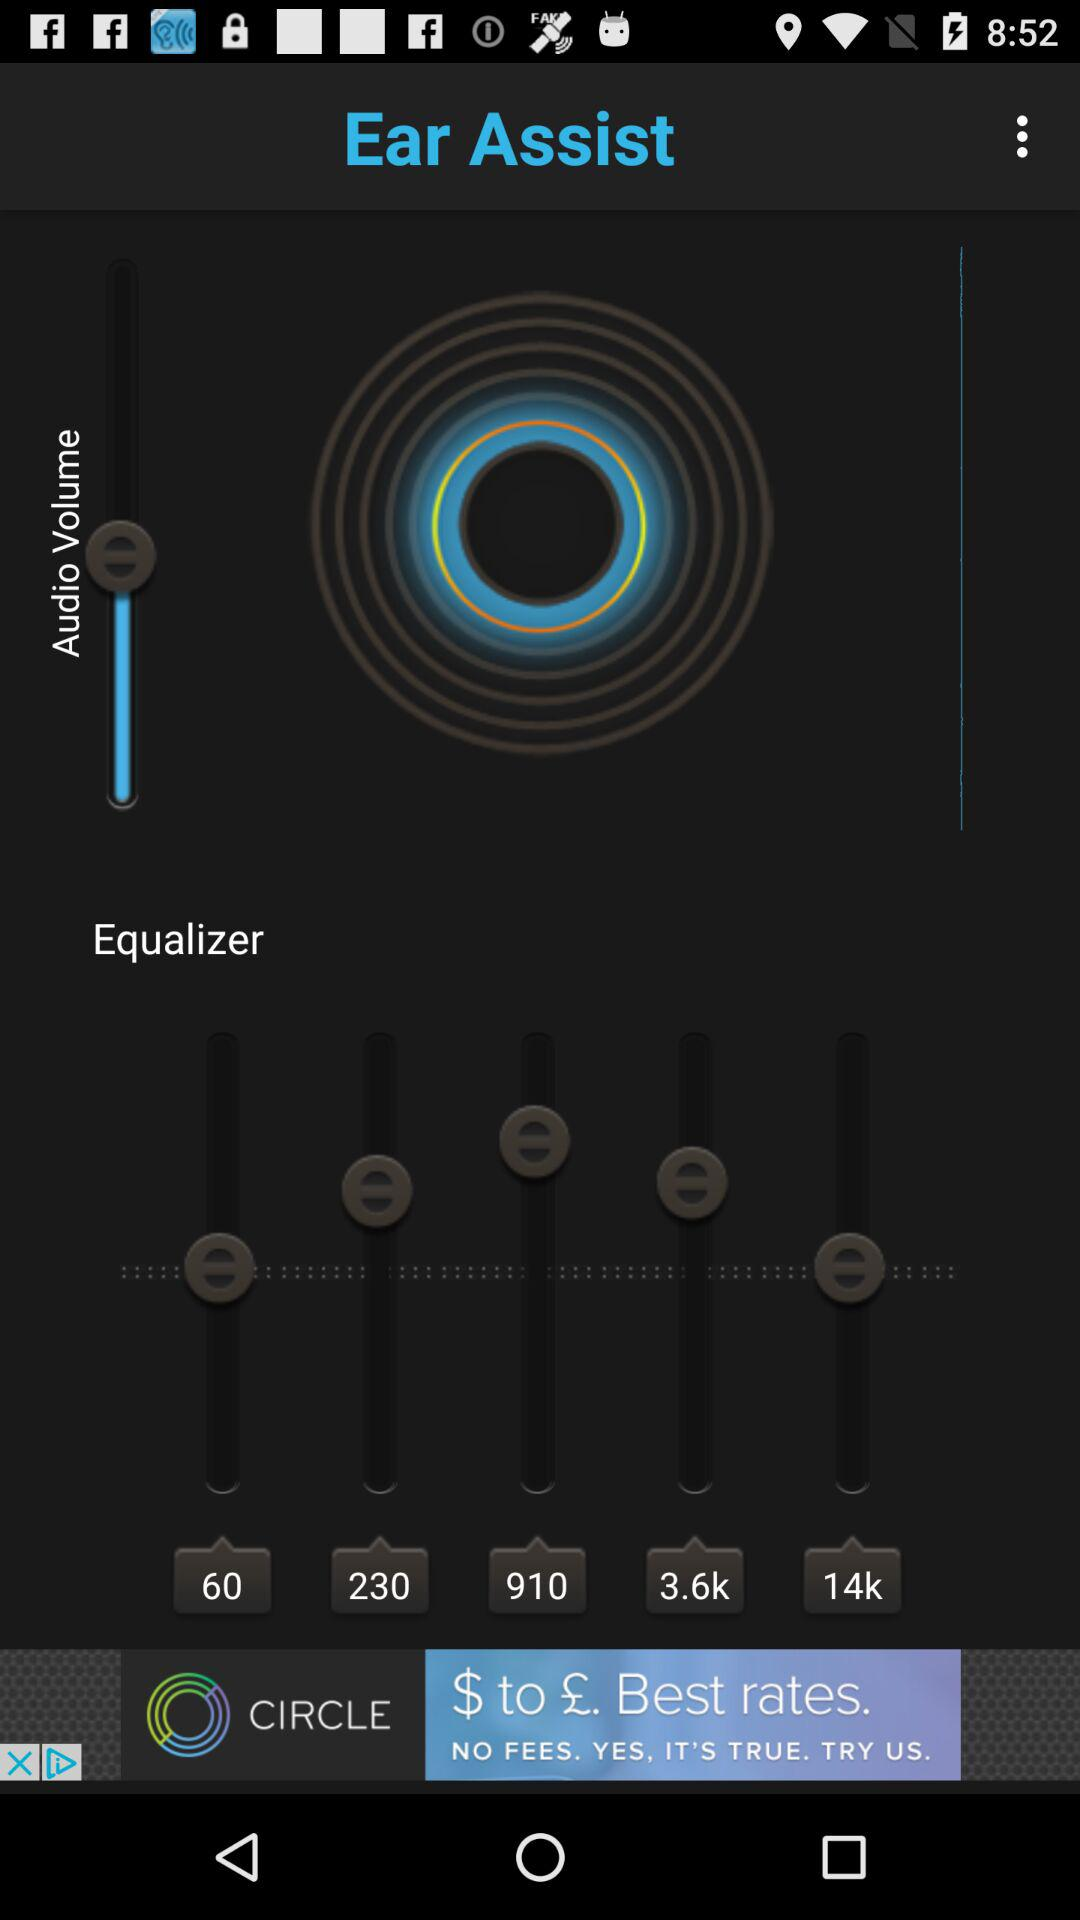What is the name of the application? The name of the application is "Ear Assist". 